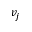Convert formula to latex. <formula><loc_0><loc_0><loc_500><loc_500>v _ { j }</formula> 